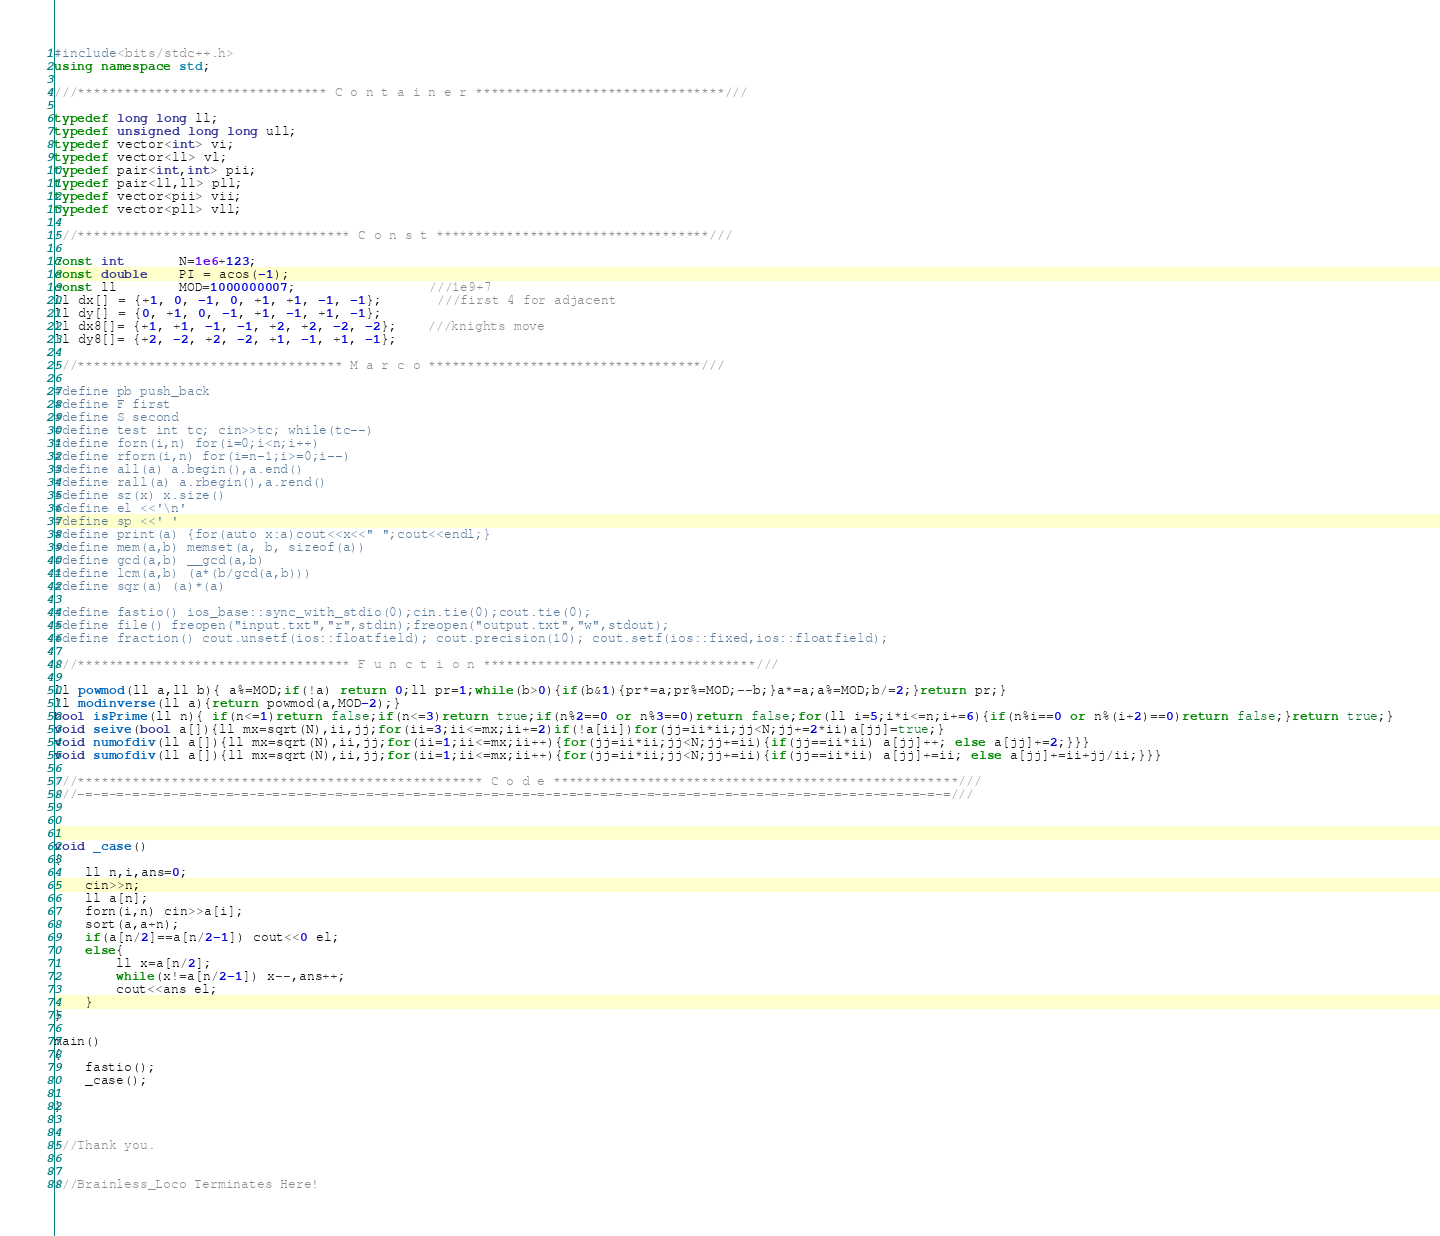<code> <loc_0><loc_0><loc_500><loc_500><_C++_>#include<bits/stdc++.h>
using namespace std;

///******************************** C o n t a i n e r ********************************///

typedef long long ll;
typedef unsigned long long ull;
typedef vector<int> vi;
typedef vector<ll> vl;
typedef pair<int,int> pii;
typedef pair<ll,ll> pll;
typedef vector<pii> vii;
typedef vector<pll> vll;

///*********************************** C o n s t ***********************************///

const int       N=1e6+123;
const double    PI = acos(-1);
const ll        MOD=1000000007;                 ///1e9+7
ll dx[] = {+1, 0, -1, 0, +1, +1, -1, -1};       ///first 4 for adjacent
ll dy[] = {0, +1, 0, -1, +1, -1, +1, -1};
ll dx8[]= {+1, +1, -1, -1, +2, +2, -2, -2};    ///knights move
ll dy8[]= {+2, -2, +2, -2, +1, -1, +1, -1};

///********************************** M a r c o ***********************************///

#define pb push_back
#define F first
#define S second
#define test int tc; cin>>tc; while(tc--)
#define forn(i,n) for(i=0;i<n;i++)
#define rforn(i,n) for(i=n-1;i>=0;i--)
#define all(a) a.begin(),a.end()
#define rall(a) a.rbegin(),a.rend()
#define sz(x) x.size()
#define el <<'\n'
#define sp <<' '
#define print(a) {for(auto x:a)cout<<x<<" ";cout<<endl;}
#define mem(a,b) memset(a, b, sizeof(a))
#define gcd(a,b) __gcd(a,b)
#define lcm(a,b) (a*(b/gcd(a,b)))
#define sqr(a) (a)*(a)

#define fastio() ios_base::sync_with_stdio(0);cin.tie(0);cout.tie(0);
#define file() freopen("input.txt","r",stdin);freopen("output.txt","w",stdout);
#define fraction() cout.unsetf(ios::floatfield); cout.precision(10); cout.setf(ios::fixed,ios::floatfield);

///*********************************** F u n c t i o n ***********************************///

ll powmod(ll a,ll b){ a%=MOD;if(!a) return 0;ll pr=1;while(b>0){if(b&1){pr*=a;pr%=MOD;--b;}a*=a;a%=MOD;b/=2;}return pr;}
ll modinverse(ll a){return powmod(a,MOD-2);}
bool isPrime(ll n){ if(n<=1)return false;if(n<=3)return true;if(n%2==0 or n%3==0)return false;for(ll i=5;i*i<=n;i+=6){if(n%i==0 or n%(i+2)==0)return false;}return true;}
void seive(bool a[]){ll mx=sqrt(N),ii,jj;for(ii=3;ii<=mx;ii+=2)if(!a[ii])for(jj=ii*ii;jj<N;jj+=2*ii)a[jj]=true;}
void numofdiv(ll a[]){ll mx=sqrt(N),ii,jj;for(ii=1;ii<=mx;ii++){for(jj=ii*ii;jj<N;jj+=ii){if(jj==ii*ii) a[jj]++; else a[jj]+=2;}}}
void sumofdiv(ll a[]){ll mx=sqrt(N),ii,jj;for(ii=1;ii<=mx;ii++){for(jj=ii*ii;jj<N;jj+=ii){if(jj==ii*ii) a[jj]+=ii; else a[jj]+=ii+jj/ii;}}}

///**************************************************** C o d e ****************************************************///
///-=-=-=-=-=-=-=-=-=-=-=-=-=-=-=-=-=-=-=-=-=-=-=-=-=-=-=-=-=-=-=-=-=-=-=-=-=-=-=-=-=-=-=-=-=-=-=-=-=-=-=-=-=-=-=-=///



void _case()
{
    ll n,i,ans=0;
    cin>>n;
    ll a[n];
    forn(i,n) cin>>a[i];
    sort(a,a+n);
    if(a[n/2]==a[n/2-1]) cout<<0 el;
    else{
        ll x=a[n/2];
        while(x!=a[n/2-1]) x--,ans++;
        cout<<ans el;
    }
}

main()
{
    fastio();
    _case();

}


///Thank you.


///Brainless_Loco Terminates Here!
</code> 